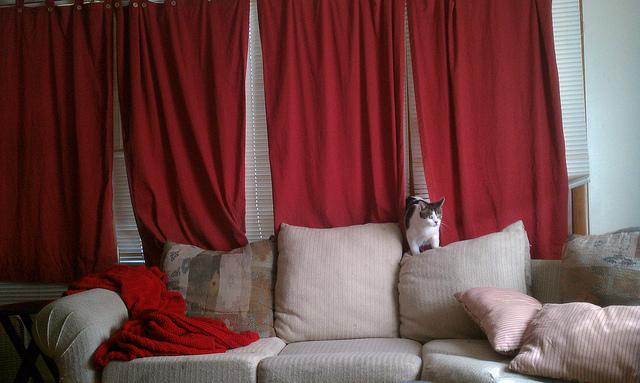How many pillows are on the couch?
Short answer required. 5. What animal is on the couch?
Quick response, please. Cat. What color are the curtains?
Keep it brief. Red. Is the cat paying attention?
Answer briefly. Yes. 